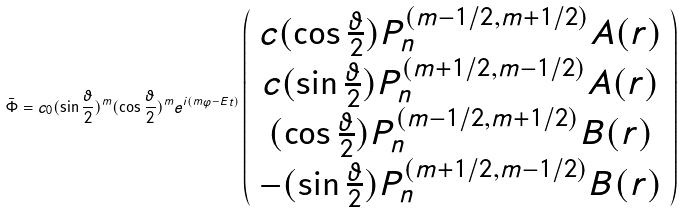Convert formula to latex. <formula><loc_0><loc_0><loc_500><loc_500>\bar { \Phi } = c _ { 0 } ( \sin \frac { \vartheta } { 2 } ) ^ { m } ( \cos \frac { \vartheta } { 2 } ) ^ { m } e ^ { i ( m \varphi - E t ) } \left ( \begin{array} { c } c ( \cos \frac { \vartheta } { 2 } ) P _ { n } ^ { ( m - 1 / 2 , m + 1 / 2 ) } A ( r ) \\ c ( \sin \frac { \vartheta } { 2 } ) P _ { n } ^ { ( m + 1 / 2 , m - 1 / 2 ) } A ( r ) \\ ( \cos \frac { \vartheta } { 2 } ) P _ { n } ^ { ( m - 1 / 2 , m + 1 / 2 ) } B ( r ) \\ - ( \sin \frac { \vartheta } { 2 } ) P _ { n } ^ { ( m + 1 / 2 , m - 1 / 2 ) } B ( r ) \end{array} \right )</formula> 